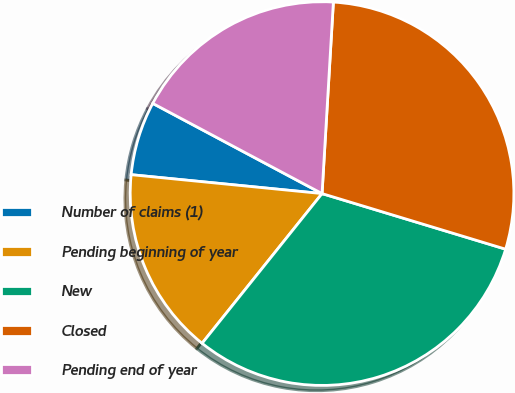<chart> <loc_0><loc_0><loc_500><loc_500><pie_chart><fcel>Number of claims (1)<fcel>Pending beginning of year<fcel>New<fcel>Closed<fcel>Pending end of year<nl><fcel>6.22%<fcel>15.82%<fcel>31.07%<fcel>28.74%<fcel>18.15%<nl></chart> 